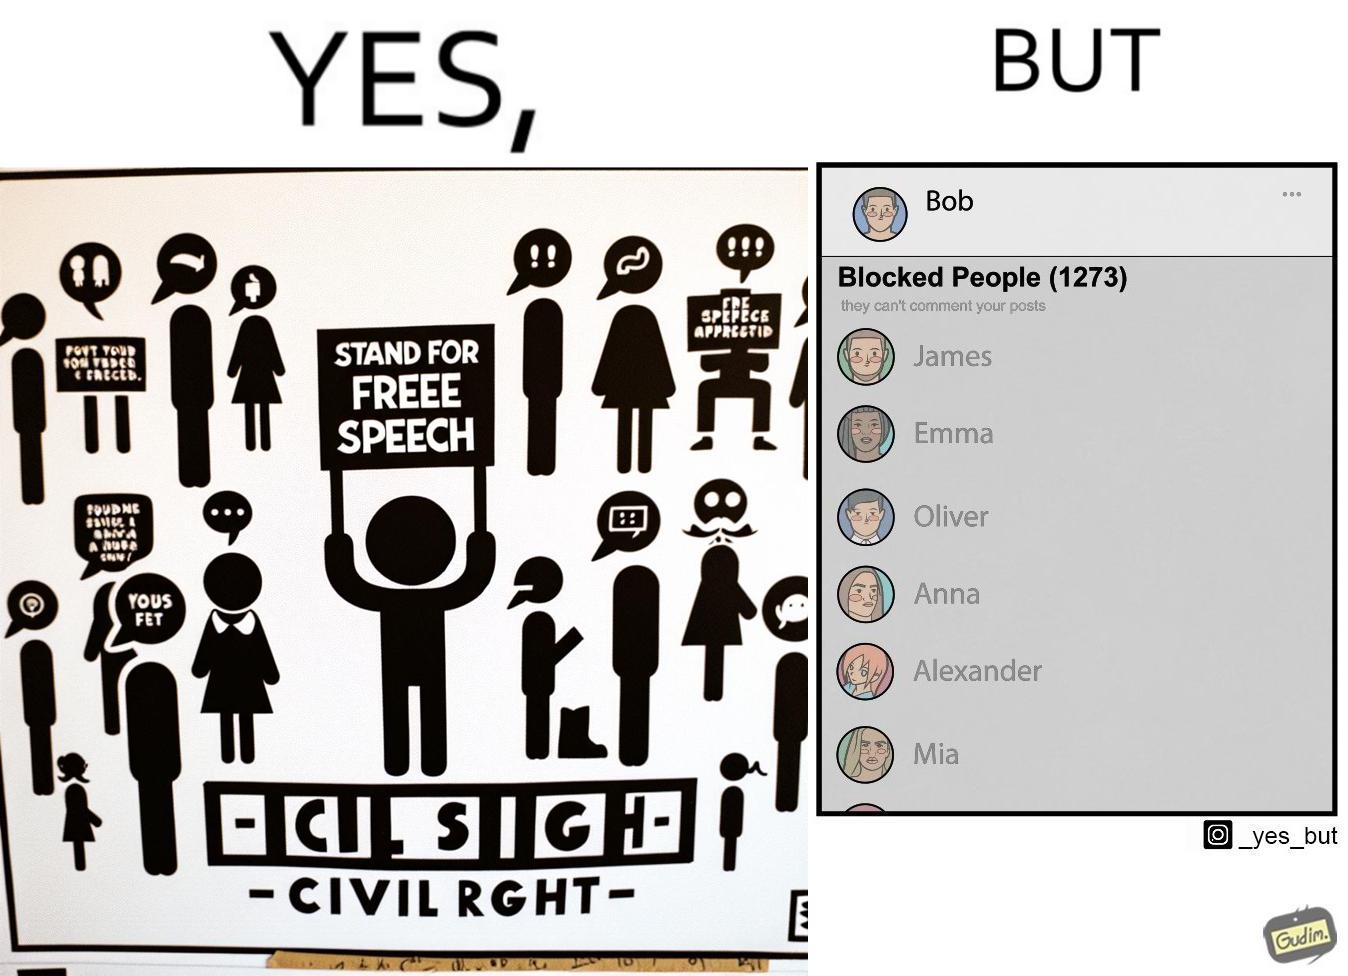What is the satirical meaning behind this image? The images are funny since even though someone like "Bob" shows support for free speech as a civil right, he is not ready to deal with the consequences of free speech and chooses to not be spoken to by certain people. He thus blocks people from contacting him on his phone. 